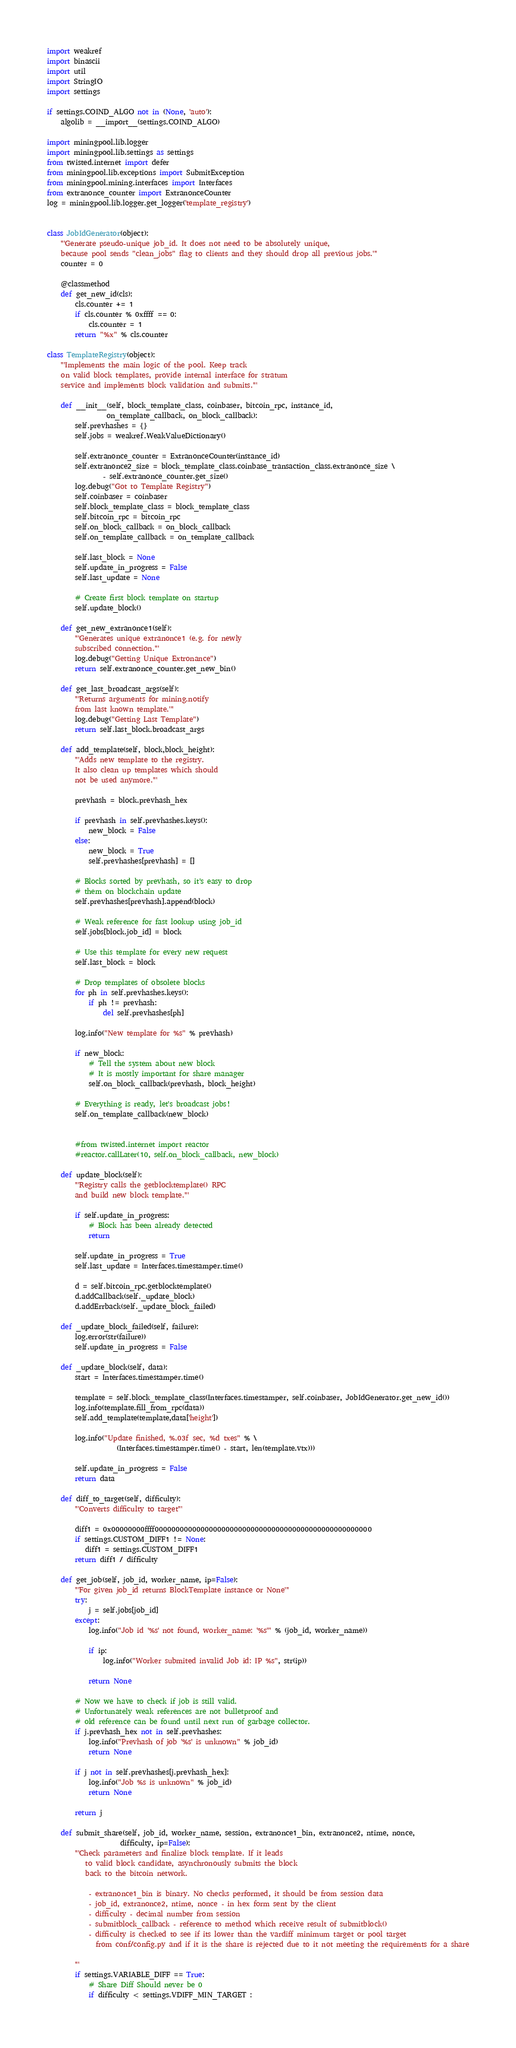Convert code to text. <code><loc_0><loc_0><loc_500><loc_500><_Python_>import weakref
import binascii
import util
import StringIO
import settings

if settings.COIND_ALGO not in (None, 'auto'):
    algolib = __import__(settings.COIND_ALGO)

import miningpool.lib.logger
import miningpool.lib.settings as settings
from twisted.internet import defer
from miningpool.lib.exceptions import SubmitException
from miningpool.mining.interfaces import Interfaces
from extranonce_counter import ExtranonceCounter
log = miningpool.lib.logger.get_logger('template_registry')


class JobIdGenerator(object):
    '''Generate pseudo-unique job_id. It does not need to be absolutely unique,
    because pool sends "clean_jobs" flag to clients and they should drop all previous jobs.'''
    counter = 0

    @classmethod
    def get_new_id(cls):
        cls.counter += 1
        if cls.counter % 0xffff == 0:
            cls.counter = 1
        return "%x" % cls.counter

class TemplateRegistry(object):
    '''Implements the main logic of the pool. Keep track
    on valid block templates, provide internal interface for stratum
    service and implements block validation and submits.'''

    def __init__(self, block_template_class, coinbaser, bitcoin_rpc, instance_id,
                 on_template_callback, on_block_callback):
        self.prevhashes = {}
        self.jobs = weakref.WeakValueDictionary()

        self.extranonce_counter = ExtranonceCounter(instance_id)
        self.extranonce2_size = block_template_class.coinbase_transaction_class.extranonce_size \
                - self.extranonce_counter.get_size()
        log.debug("Got to Template Registry")
        self.coinbaser = coinbaser
        self.block_template_class = block_template_class
        self.bitcoin_rpc = bitcoin_rpc
        self.on_block_callback = on_block_callback
        self.on_template_callback = on_template_callback

        self.last_block = None
        self.update_in_progress = False
        self.last_update = None

        # Create first block template on startup
        self.update_block()

    def get_new_extranonce1(self):
        '''Generates unique extranonce1 (e.g. for newly
        subscribed connection.'''
        log.debug("Getting Unique Extronance")
        return self.extranonce_counter.get_new_bin()

    def get_last_broadcast_args(self):
        '''Returns arguments for mining.notify
        from last known template.'''
        log.debug("Getting Last Template")
        return self.last_block.broadcast_args

    def add_template(self, block,block_height):
        '''Adds new template to the registry.
        It also clean up templates which should
        not be used anymore.'''

        prevhash = block.prevhash_hex

        if prevhash in self.prevhashes.keys():
            new_block = False
        else:
            new_block = True
            self.prevhashes[prevhash] = []

        # Blocks sorted by prevhash, so it's easy to drop
        # them on blockchain update
        self.prevhashes[prevhash].append(block)

        # Weak reference for fast lookup using job_id
        self.jobs[block.job_id] = block

        # Use this template for every new request
        self.last_block = block

        # Drop templates of obsolete blocks
        for ph in self.prevhashes.keys():
            if ph != prevhash:
                del self.prevhashes[ph]

        log.info("New template for %s" % prevhash)

        if new_block:
            # Tell the system about new block
            # It is mostly important for share manager
            self.on_block_callback(prevhash, block_height)

        # Everything is ready, let's broadcast jobs!
        self.on_template_callback(new_block)


        #from twisted.internet import reactor
        #reactor.callLater(10, self.on_block_callback, new_block)

    def update_block(self):
        '''Registry calls the getblocktemplate() RPC
        and build new block template.'''

        if self.update_in_progress:
            # Block has been already detected
            return

        self.update_in_progress = True
        self.last_update = Interfaces.timestamper.time()

        d = self.bitcoin_rpc.getblocktemplate()
        d.addCallback(self._update_block)
        d.addErrback(self._update_block_failed)

    def _update_block_failed(self, failure):
        log.error(str(failure))
        self.update_in_progress = False

    def _update_block(self, data):
        start = Interfaces.timestamper.time()

        template = self.block_template_class(Interfaces.timestamper, self.coinbaser, JobIdGenerator.get_new_id())
        log.info(template.fill_from_rpc(data))
        self.add_template(template,data['height'])

        log.info("Update finished, %.03f sec, %d txes" % \
                    (Interfaces.timestamper.time() - start, len(template.vtx)))

        self.update_in_progress = False
        return data

    def diff_to_target(self, difficulty):
        '''Converts difficulty to target'''

        diff1 = 0x00000000ffff0000000000000000000000000000000000000000000000000000
        if settings.CUSTOM_DIFF1 != None:
           diff1 = settings.CUSTOM_DIFF1
        return diff1 / difficulty

    def get_job(self, job_id, worker_name, ip=False):
        '''For given job_id returns BlockTemplate instance or None'''
        try:
            j = self.jobs[job_id]
        except:
            log.info("Job id '%s' not found, worker_name: '%s'" % (job_id, worker_name))

            if ip:
                log.info("Worker submited invalid Job id: IP %s", str(ip))

            return None

        # Now we have to check if job is still valid.
        # Unfortunately weak references are not bulletproof and
        # old reference can be found until next run of garbage collector.
        if j.prevhash_hex not in self.prevhashes:
            log.info("Prevhash of job '%s' is unknown" % job_id)
            return None

        if j not in self.prevhashes[j.prevhash_hex]:
            log.info("Job %s is unknown" % job_id)
            return None

        return j

    def submit_share(self, job_id, worker_name, session, extranonce1_bin, extranonce2, ntime, nonce,
                     difficulty, ip=False):
        '''Check parameters and finalize block template. If it leads
           to valid block candidate, asynchronously submits the block
           back to the bitcoin network.

            - extranonce1_bin is binary. No checks performed, it should be from session data
            - job_id, extranonce2, ntime, nonce - in hex form sent by the client
            - difficulty - decimal number from session
            - submitblock_callback - reference to method which receive result of submitblock()
            - difficulty is checked to see if its lower than the vardiff minimum target or pool target
              from conf/config.py and if it is the share is rejected due to it not meeting the requirements for a share

        '''
        if settings.VARIABLE_DIFF == True:
            # Share Diff Should never be 0
            if difficulty < settings.VDIFF_MIN_TARGET :</code> 